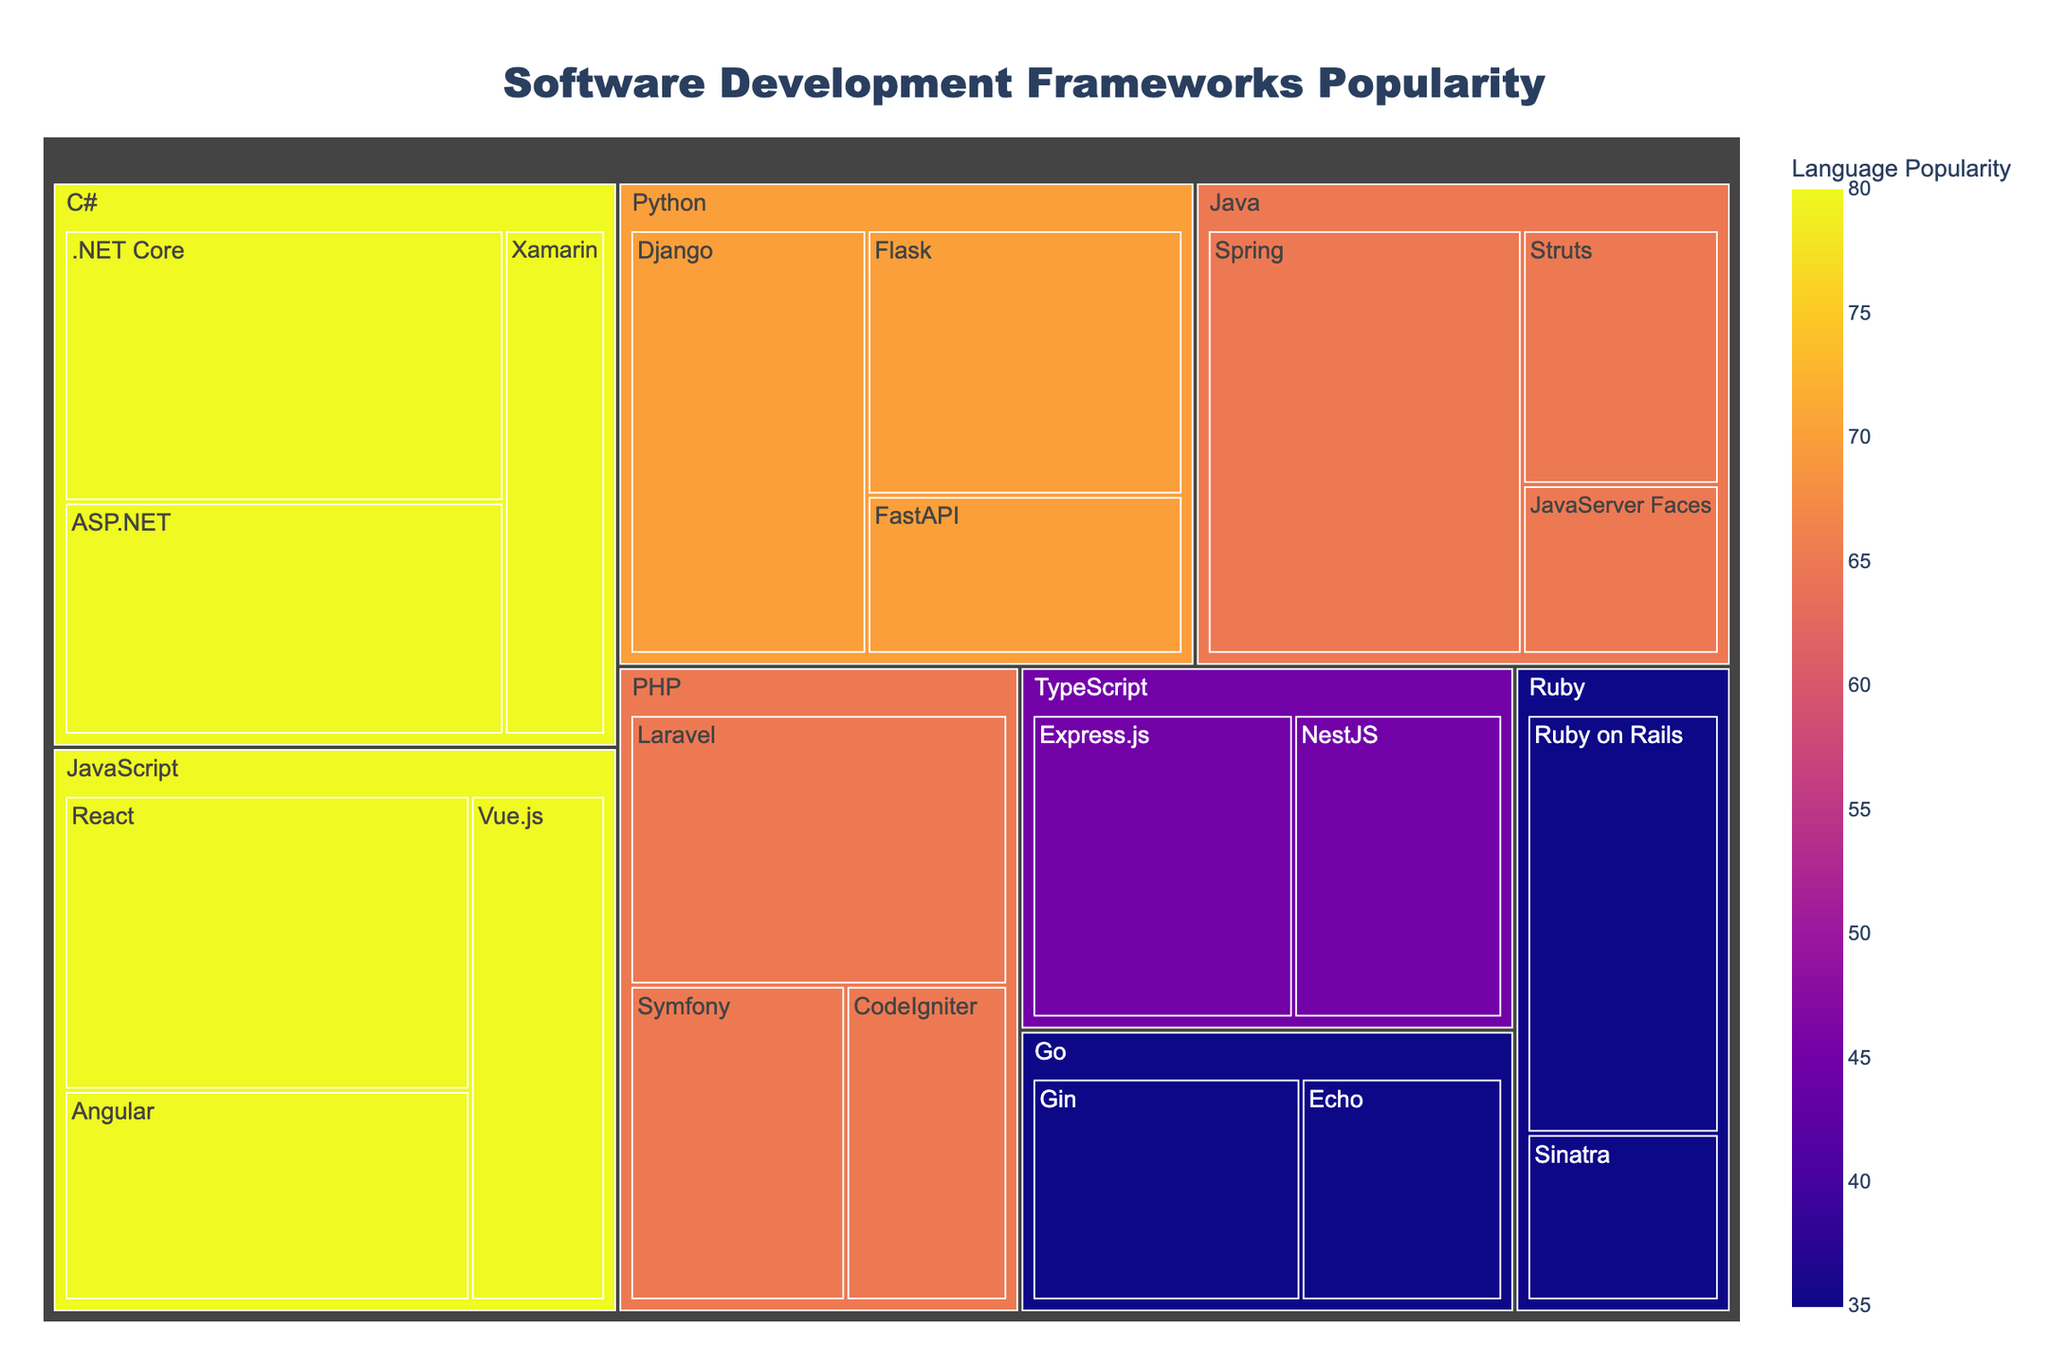What is the most popular framework overall? From the treemap, the size of each rectangle represents the popularity. The largest rectangle belongs to the Java framework "Spring" with a popularity value of 40.
Answer: Spring Which language has the highest total popularity based on the color scale? The color scale represents the total popularity of each language, with darker colors indicating higher popularity. Java, with the darkest color, has the highest total popularity.
Answer: Java What is the popularity difference between React and Angular frameworks in the JavaScript category? According to the treemap, React has a popularity of 35, and Angular has a popularity of 25. So the difference is 35 - 25 = 10.
Answer: 10 Which framework has higher popularity in Python: Flask or FastAPI? From the treemap, Flask has a popularity of 25, and FastAPI has a popularity of 15. Therefore, Flask is more popular.
Answer: Flask What's the total popularity of all frameworks in the PHP language? To find this, sum the individual popularity values for PHP frameworks: Laravel (30) + Symfony (20) + CodeIgniter (15) = 65.
Answer: 65 How many frameworks in the treemap have a popularity greater than 25? From the treemap, the frameworks with popularity greater than 25 are React (35), Angular (25), Django (30), Spring (40), .NET Core (35), and ASP.NET (30). That's 6 frameworks in total.
Answer: 6 Which framework is more popular, Django or NestJS? In the treemap, Django (Python) has a popularity of 30, whereas NestJS (TypeScript) has a popularity of 20. Thus, Django is more popular.
Answer: Django Order TypeScript frameworks by popularity from highest to lowest. From the treemap, TypeScript frameworks ordered by popularity are: Express.js (25), NestJS (20).
Answer: Express.js, NestJS What is the second most popular framework in C#? From the treemap, after .NET Core (35), the second most popular framework in C# is ASP.NET with a popularity of 30.
Answer: ASP.NET 